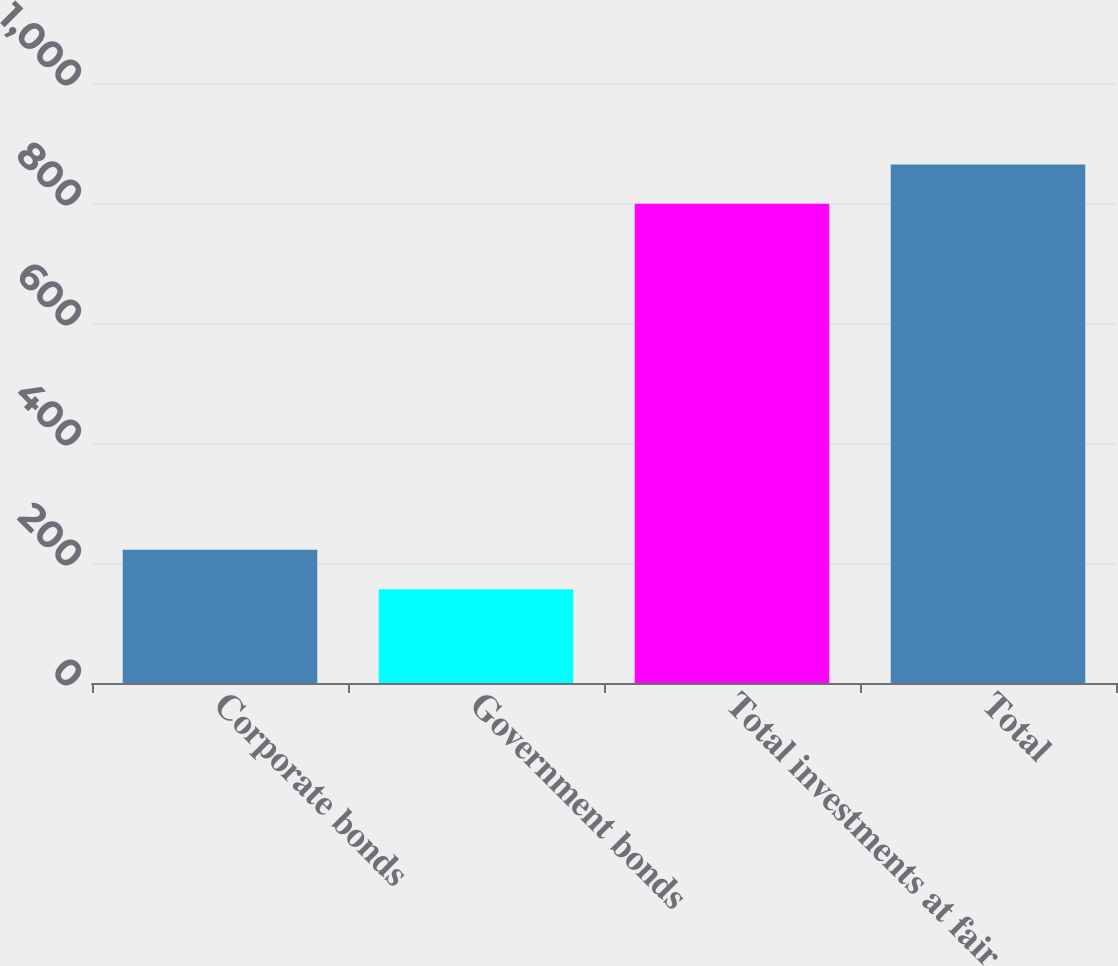Convert chart to OTSL. <chart><loc_0><loc_0><loc_500><loc_500><bar_chart><fcel>Corporate bonds<fcel>Government bonds<fcel>Total investments at fair<fcel>Total<nl><fcel>222.02<fcel>156.3<fcel>798.6<fcel>864.32<nl></chart> 